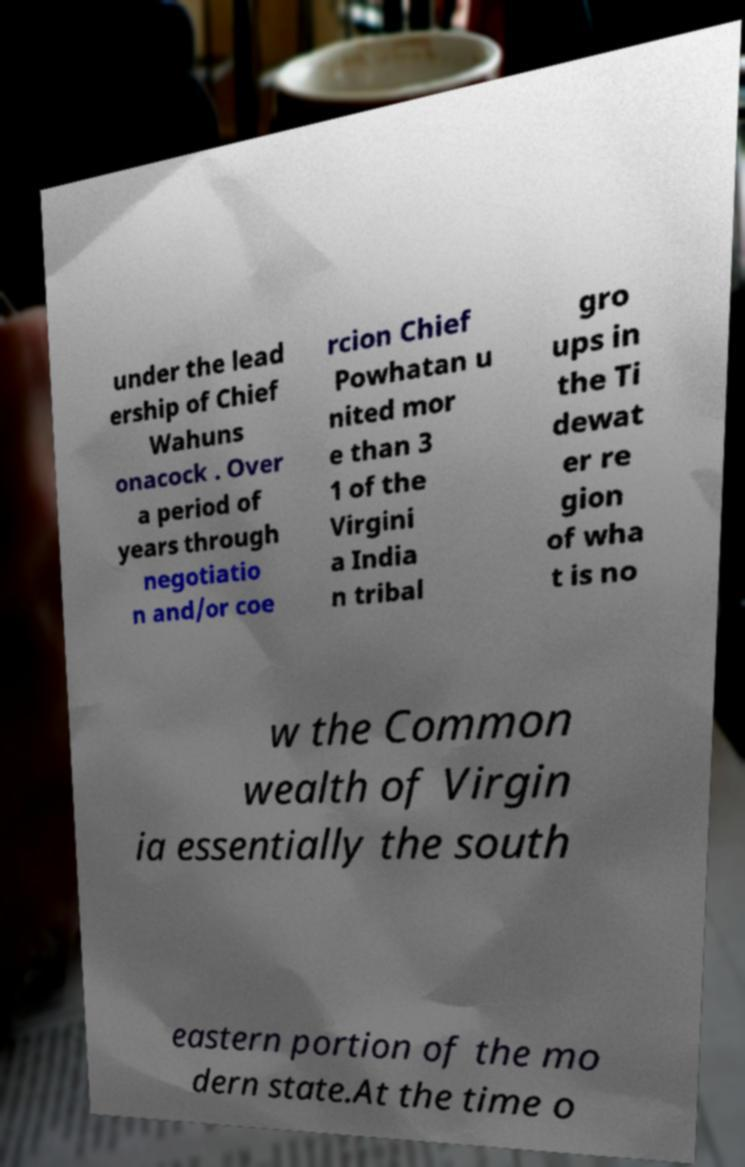Please read and relay the text visible in this image. What does it say? under the lead ership of Chief Wahuns onacock . Over a period of years through negotiatio n and/or coe rcion Chief Powhatan u nited mor e than 3 1 of the Virgini a India n tribal gro ups in the Ti dewat er re gion of wha t is no w the Common wealth of Virgin ia essentially the south eastern portion of the mo dern state.At the time o 